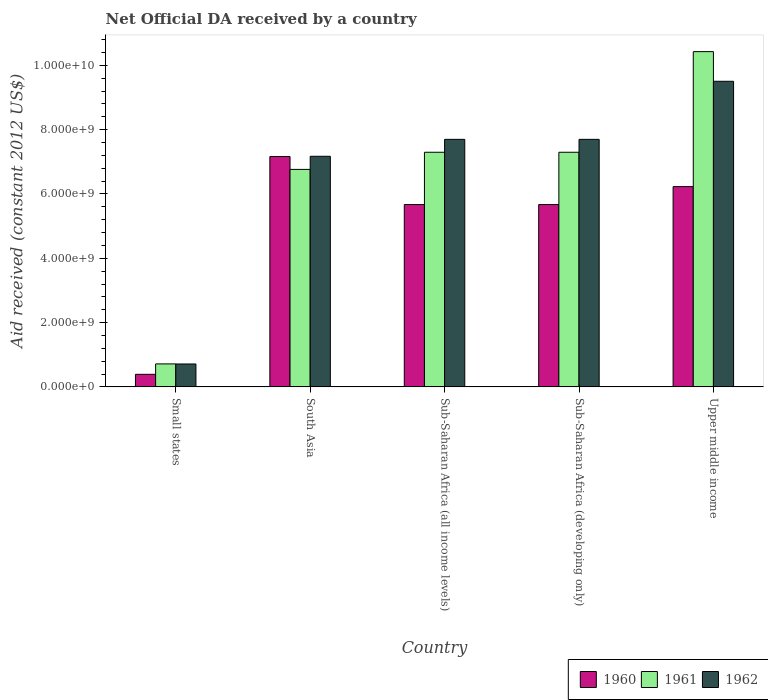How many different coloured bars are there?
Provide a short and direct response. 3. How many groups of bars are there?
Your answer should be compact. 5. How many bars are there on the 3rd tick from the left?
Make the answer very short. 3. What is the label of the 1st group of bars from the left?
Provide a succinct answer. Small states. In how many cases, is the number of bars for a given country not equal to the number of legend labels?
Your answer should be very brief. 0. What is the net official development assistance aid received in 1960 in Upper middle income?
Your answer should be very brief. 6.23e+09. Across all countries, what is the maximum net official development assistance aid received in 1960?
Provide a short and direct response. 7.17e+09. Across all countries, what is the minimum net official development assistance aid received in 1962?
Offer a very short reply. 7.12e+08. In which country was the net official development assistance aid received in 1962 maximum?
Provide a succinct answer. Upper middle income. In which country was the net official development assistance aid received in 1962 minimum?
Your answer should be very brief. Small states. What is the total net official development assistance aid received in 1962 in the graph?
Your response must be concise. 3.28e+1. What is the difference between the net official development assistance aid received in 1962 in South Asia and that in Sub-Saharan Africa (all income levels)?
Offer a very short reply. -5.27e+08. What is the difference between the net official development assistance aid received in 1961 in Small states and the net official development assistance aid received in 1962 in South Asia?
Provide a succinct answer. -6.46e+09. What is the average net official development assistance aid received in 1960 per country?
Offer a terse response. 5.03e+09. What is the difference between the net official development assistance aid received of/in 1960 and net official development assistance aid received of/in 1961 in Small states?
Provide a short and direct response. -3.24e+08. What is the ratio of the net official development assistance aid received in 1961 in Small states to that in Upper middle income?
Your answer should be very brief. 0.07. What is the difference between the highest and the second highest net official development assistance aid received in 1962?
Provide a short and direct response. 1.81e+09. What is the difference between the highest and the lowest net official development assistance aid received in 1961?
Give a very brief answer. 9.71e+09. In how many countries, is the net official development assistance aid received in 1962 greater than the average net official development assistance aid received in 1962 taken over all countries?
Offer a terse response. 4. Is it the case that in every country, the sum of the net official development assistance aid received in 1960 and net official development assistance aid received in 1961 is greater than the net official development assistance aid received in 1962?
Provide a short and direct response. Yes. How many bars are there?
Your answer should be compact. 15. How many countries are there in the graph?
Offer a terse response. 5. Does the graph contain any zero values?
Ensure brevity in your answer.  No. Where does the legend appear in the graph?
Your answer should be very brief. Bottom right. What is the title of the graph?
Give a very brief answer. Net Official DA received by a country. What is the label or title of the X-axis?
Keep it short and to the point. Country. What is the label or title of the Y-axis?
Your answer should be compact. Aid received (constant 2012 US$). What is the Aid received (constant 2012 US$) of 1960 in Small states?
Give a very brief answer. 3.90e+08. What is the Aid received (constant 2012 US$) in 1961 in Small states?
Provide a short and direct response. 7.15e+08. What is the Aid received (constant 2012 US$) in 1962 in Small states?
Your answer should be compact. 7.12e+08. What is the Aid received (constant 2012 US$) in 1960 in South Asia?
Your answer should be compact. 7.17e+09. What is the Aid received (constant 2012 US$) in 1961 in South Asia?
Keep it short and to the point. 6.76e+09. What is the Aid received (constant 2012 US$) in 1962 in South Asia?
Offer a very short reply. 7.17e+09. What is the Aid received (constant 2012 US$) in 1960 in Sub-Saharan Africa (all income levels)?
Provide a short and direct response. 5.67e+09. What is the Aid received (constant 2012 US$) of 1961 in Sub-Saharan Africa (all income levels)?
Provide a short and direct response. 7.30e+09. What is the Aid received (constant 2012 US$) of 1962 in Sub-Saharan Africa (all income levels)?
Offer a very short reply. 7.70e+09. What is the Aid received (constant 2012 US$) in 1960 in Sub-Saharan Africa (developing only)?
Give a very brief answer. 5.67e+09. What is the Aid received (constant 2012 US$) of 1961 in Sub-Saharan Africa (developing only)?
Offer a very short reply. 7.30e+09. What is the Aid received (constant 2012 US$) of 1962 in Sub-Saharan Africa (developing only)?
Your answer should be very brief. 7.70e+09. What is the Aid received (constant 2012 US$) in 1960 in Upper middle income?
Your answer should be very brief. 6.23e+09. What is the Aid received (constant 2012 US$) of 1961 in Upper middle income?
Offer a terse response. 1.04e+1. What is the Aid received (constant 2012 US$) in 1962 in Upper middle income?
Your answer should be compact. 9.51e+09. Across all countries, what is the maximum Aid received (constant 2012 US$) in 1960?
Ensure brevity in your answer.  7.17e+09. Across all countries, what is the maximum Aid received (constant 2012 US$) in 1961?
Your answer should be compact. 1.04e+1. Across all countries, what is the maximum Aid received (constant 2012 US$) in 1962?
Offer a very short reply. 9.51e+09. Across all countries, what is the minimum Aid received (constant 2012 US$) in 1960?
Offer a terse response. 3.90e+08. Across all countries, what is the minimum Aid received (constant 2012 US$) in 1961?
Keep it short and to the point. 7.15e+08. Across all countries, what is the minimum Aid received (constant 2012 US$) in 1962?
Provide a succinct answer. 7.12e+08. What is the total Aid received (constant 2012 US$) of 1960 in the graph?
Ensure brevity in your answer.  2.51e+1. What is the total Aid received (constant 2012 US$) of 1961 in the graph?
Offer a terse response. 3.25e+1. What is the total Aid received (constant 2012 US$) of 1962 in the graph?
Offer a terse response. 3.28e+1. What is the difference between the Aid received (constant 2012 US$) of 1960 in Small states and that in South Asia?
Give a very brief answer. -6.77e+09. What is the difference between the Aid received (constant 2012 US$) in 1961 in Small states and that in South Asia?
Make the answer very short. -6.05e+09. What is the difference between the Aid received (constant 2012 US$) of 1962 in Small states and that in South Asia?
Offer a very short reply. -6.46e+09. What is the difference between the Aid received (constant 2012 US$) of 1960 in Small states and that in Sub-Saharan Africa (all income levels)?
Your answer should be compact. -5.28e+09. What is the difference between the Aid received (constant 2012 US$) in 1961 in Small states and that in Sub-Saharan Africa (all income levels)?
Your response must be concise. -6.58e+09. What is the difference between the Aid received (constant 2012 US$) in 1962 in Small states and that in Sub-Saharan Africa (all income levels)?
Ensure brevity in your answer.  -6.99e+09. What is the difference between the Aid received (constant 2012 US$) of 1960 in Small states and that in Sub-Saharan Africa (developing only)?
Your answer should be compact. -5.28e+09. What is the difference between the Aid received (constant 2012 US$) of 1961 in Small states and that in Sub-Saharan Africa (developing only)?
Offer a very short reply. -6.58e+09. What is the difference between the Aid received (constant 2012 US$) in 1962 in Small states and that in Sub-Saharan Africa (developing only)?
Your answer should be very brief. -6.99e+09. What is the difference between the Aid received (constant 2012 US$) in 1960 in Small states and that in Upper middle income?
Provide a succinct answer. -5.84e+09. What is the difference between the Aid received (constant 2012 US$) in 1961 in Small states and that in Upper middle income?
Offer a very short reply. -9.71e+09. What is the difference between the Aid received (constant 2012 US$) of 1962 in Small states and that in Upper middle income?
Your answer should be very brief. -8.79e+09. What is the difference between the Aid received (constant 2012 US$) in 1960 in South Asia and that in Sub-Saharan Africa (all income levels)?
Offer a very short reply. 1.49e+09. What is the difference between the Aid received (constant 2012 US$) in 1961 in South Asia and that in Sub-Saharan Africa (all income levels)?
Offer a very short reply. -5.34e+08. What is the difference between the Aid received (constant 2012 US$) of 1962 in South Asia and that in Sub-Saharan Africa (all income levels)?
Provide a short and direct response. -5.27e+08. What is the difference between the Aid received (constant 2012 US$) of 1960 in South Asia and that in Sub-Saharan Africa (developing only)?
Your answer should be very brief. 1.49e+09. What is the difference between the Aid received (constant 2012 US$) in 1961 in South Asia and that in Sub-Saharan Africa (developing only)?
Make the answer very short. -5.34e+08. What is the difference between the Aid received (constant 2012 US$) in 1962 in South Asia and that in Sub-Saharan Africa (developing only)?
Keep it short and to the point. -5.27e+08. What is the difference between the Aid received (constant 2012 US$) of 1960 in South Asia and that in Upper middle income?
Offer a terse response. 9.35e+08. What is the difference between the Aid received (constant 2012 US$) of 1961 in South Asia and that in Upper middle income?
Ensure brevity in your answer.  -3.66e+09. What is the difference between the Aid received (constant 2012 US$) of 1962 in South Asia and that in Upper middle income?
Offer a very short reply. -2.33e+09. What is the difference between the Aid received (constant 2012 US$) of 1961 in Sub-Saharan Africa (all income levels) and that in Sub-Saharan Africa (developing only)?
Keep it short and to the point. 0. What is the difference between the Aid received (constant 2012 US$) in 1960 in Sub-Saharan Africa (all income levels) and that in Upper middle income?
Keep it short and to the point. -5.58e+08. What is the difference between the Aid received (constant 2012 US$) in 1961 in Sub-Saharan Africa (all income levels) and that in Upper middle income?
Ensure brevity in your answer.  -3.13e+09. What is the difference between the Aid received (constant 2012 US$) in 1962 in Sub-Saharan Africa (all income levels) and that in Upper middle income?
Ensure brevity in your answer.  -1.81e+09. What is the difference between the Aid received (constant 2012 US$) in 1960 in Sub-Saharan Africa (developing only) and that in Upper middle income?
Offer a very short reply. -5.58e+08. What is the difference between the Aid received (constant 2012 US$) in 1961 in Sub-Saharan Africa (developing only) and that in Upper middle income?
Your response must be concise. -3.13e+09. What is the difference between the Aid received (constant 2012 US$) of 1962 in Sub-Saharan Africa (developing only) and that in Upper middle income?
Your response must be concise. -1.81e+09. What is the difference between the Aid received (constant 2012 US$) of 1960 in Small states and the Aid received (constant 2012 US$) of 1961 in South Asia?
Your answer should be compact. -6.37e+09. What is the difference between the Aid received (constant 2012 US$) in 1960 in Small states and the Aid received (constant 2012 US$) in 1962 in South Asia?
Provide a short and direct response. -6.78e+09. What is the difference between the Aid received (constant 2012 US$) of 1961 in Small states and the Aid received (constant 2012 US$) of 1962 in South Asia?
Provide a short and direct response. -6.46e+09. What is the difference between the Aid received (constant 2012 US$) of 1960 in Small states and the Aid received (constant 2012 US$) of 1961 in Sub-Saharan Africa (all income levels)?
Provide a succinct answer. -6.91e+09. What is the difference between the Aid received (constant 2012 US$) in 1960 in Small states and the Aid received (constant 2012 US$) in 1962 in Sub-Saharan Africa (all income levels)?
Provide a short and direct response. -7.31e+09. What is the difference between the Aid received (constant 2012 US$) in 1961 in Small states and the Aid received (constant 2012 US$) in 1962 in Sub-Saharan Africa (all income levels)?
Offer a very short reply. -6.99e+09. What is the difference between the Aid received (constant 2012 US$) in 1960 in Small states and the Aid received (constant 2012 US$) in 1961 in Sub-Saharan Africa (developing only)?
Your answer should be compact. -6.91e+09. What is the difference between the Aid received (constant 2012 US$) in 1960 in Small states and the Aid received (constant 2012 US$) in 1962 in Sub-Saharan Africa (developing only)?
Ensure brevity in your answer.  -7.31e+09. What is the difference between the Aid received (constant 2012 US$) of 1961 in Small states and the Aid received (constant 2012 US$) of 1962 in Sub-Saharan Africa (developing only)?
Provide a succinct answer. -6.99e+09. What is the difference between the Aid received (constant 2012 US$) of 1960 in Small states and the Aid received (constant 2012 US$) of 1961 in Upper middle income?
Ensure brevity in your answer.  -1.00e+1. What is the difference between the Aid received (constant 2012 US$) of 1960 in Small states and the Aid received (constant 2012 US$) of 1962 in Upper middle income?
Provide a succinct answer. -9.12e+09. What is the difference between the Aid received (constant 2012 US$) of 1961 in Small states and the Aid received (constant 2012 US$) of 1962 in Upper middle income?
Your answer should be very brief. -8.79e+09. What is the difference between the Aid received (constant 2012 US$) of 1960 in South Asia and the Aid received (constant 2012 US$) of 1961 in Sub-Saharan Africa (all income levels)?
Ensure brevity in your answer.  -1.33e+08. What is the difference between the Aid received (constant 2012 US$) of 1960 in South Asia and the Aid received (constant 2012 US$) of 1962 in Sub-Saharan Africa (all income levels)?
Your answer should be very brief. -5.35e+08. What is the difference between the Aid received (constant 2012 US$) in 1961 in South Asia and the Aid received (constant 2012 US$) in 1962 in Sub-Saharan Africa (all income levels)?
Provide a short and direct response. -9.35e+08. What is the difference between the Aid received (constant 2012 US$) in 1960 in South Asia and the Aid received (constant 2012 US$) in 1961 in Sub-Saharan Africa (developing only)?
Your response must be concise. -1.33e+08. What is the difference between the Aid received (constant 2012 US$) of 1960 in South Asia and the Aid received (constant 2012 US$) of 1962 in Sub-Saharan Africa (developing only)?
Ensure brevity in your answer.  -5.35e+08. What is the difference between the Aid received (constant 2012 US$) in 1961 in South Asia and the Aid received (constant 2012 US$) in 1962 in Sub-Saharan Africa (developing only)?
Make the answer very short. -9.35e+08. What is the difference between the Aid received (constant 2012 US$) in 1960 in South Asia and the Aid received (constant 2012 US$) in 1961 in Upper middle income?
Your answer should be compact. -3.26e+09. What is the difference between the Aid received (constant 2012 US$) of 1960 in South Asia and the Aid received (constant 2012 US$) of 1962 in Upper middle income?
Your answer should be compact. -2.34e+09. What is the difference between the Aid received (constant 2012 US$) in 1961 in South Asia and the Aid received (constant 2012 US$) in 1962 in Upper middle income?
Offer a very short reply. -2.74e+09. What is the difference between the Aid received (constant 2012 US$) in 1960 in Sub-Saharan Africa (all income levels) and the Aid received (constant 2012 US$) in 1961 in Sub-Saharan Africa (developing only)?
Your response must be concise. -1.63e+09. What is the difference between the Aid received (constant 2012 US$) in 1960 in Sub-Saharan Africa (all income levels) and the Aid received (constant 2012 US$) in 1962 in Sub-Saharan Africa (developing only)?
Give a very brief answer. -2.03e+09. What is the difference between the Aid received (constant 2012 US$) in 1961 in Sub-Saharan Africa (all income levels) and the Aid received (constant 2012 US$) in 1962 in Sub-Saharan Africa (developing only)?
Ensure brevity in your answer.  -4.02e+08. What is the difference between the Aid received (constant 2012 US$) in 1960 in Sub-Saharan Africa (all income levels) and the Aid received (constant 2012 US$) in 1961 in Upper middle income?
Make the answer very short. -4.76e+09. What is the difference between the Aid received (constant 2012 US$) of 1960 in Sub-Saharan Africa (all income levels) and the Aid received (constant 2012 US$) of 1962 in Upper middle income?
Provide a succinct answer. -3.83e+09. What is the difference between the Aid received (constant 2012 US$) of 1961 in Sub-Saharan Africa (all income levels) and the Aid received (constant 2012 US$) of 1962 in Upper middle income?
Keep it short and to the point. -2.21e+09. What is the difference between the Aid received (constant 2012 US$) in 1960 in Sub-Saharan Africa (developing only) and the Aid received (constant 2012 US$) in 1961 in Upper middle income?
Provide a short and direct response. -4.76e+09. What is the difference between the Aid received (constant 2012 US$) in 1960 in Sub-Saharan Africa (developing only) and the Aid received (constant 2012 US$) in 1962 in Upper middle income?
Provide a succinct answer. -3.83e+09. What is the difference between the Aid received (constant 2012 US$) in 1961 in Sub-Saharan Africa (developing only) and the Aid received (constant 2012 US$) in 1962 in Upper middle income?
Ensure brevity in your answer.  -2.21e+09. What is the average Aid received (constant 2012 US$) of 1960 per country?
Provide a succinct answer. 5.03e+09. What is the average Aid received (constant 2012 US$) of 1961 per country?
Make the answer very short. 6.50e+09. What is the average Aid received (constant 2012 US$) in 1962 per country?
Your answer should be very brief. 6.56e+09. What is the difference between the Aid received (constant 2012 US$) of 1960 and Aid received (constant 2012 US$) of 1961 in Small states?
Provide a succinct answer. -3.24e+08. What is the difference between the Aid received (constant 2012 US$) in 1960 and Aid received (constant 2012 US$) in 1962 in Small states?
Provide a short and direct response. -3.22e+08. What is the difference between the Aid received (constant 2012 US$) in 1961 and Aid received (constant 2012 US$) in 1962 in Small states?
Keep it short and to the point. 2.71e+06. What is the difference between the Aid received (constant 2012 US$) in 1960 and Aid received (constant 2012 US$) in 1961 in South Asia?
Your response must be concise. 4.00e+08. What is the difference between the Aid received (constant 2012 US$) in 1960 and Aid received (constant 2012 US$) in 1962 in South Asia?
Your answer should be very brief. -8.03e+06. What is the difference between the Aid received (constant 2012 US$) in 1961 and Aid received (constant 2012 US$) in 1962 in South Asia?
Ensure brevity in your answer.  -4.08e+08. What is the difference between the Aid received (constant 2012 US$) in 1960 and Aid received (constant 2012 US$) in 1961 in Sub-Saharan Africa (all income levels)?
Give a very brief answer. -1.63e+09. What is the difference between the Aid received (constant 2012 US$) in 1960 and Aid received (constant 2012 US$) in 1962 in Sub-Saharan Africa (all income levels)?
Give a very brief answer. -2.03e+09. What is the difference between the Aid received (constant 2012 US$) in 1961 and Aid received (constant 2012 US$) in 1962 in Sub-Saharan Africa (all income levels)?
Your response must be concise. -4.02e+08. What is the difference between the Aid received (constant 2012 US$) of 1960 and Aid received (constant 2012 US$) of 1961 in Sub-Saharan Africa (developing only)?
Provide a succinct answer. -1.63e+09. What is the difference between the Aid received (constant 2012 US$) in 1960 and Aid received (constant 2012 US$) in 1962 in Sub-Saharan Africa (developing only)?
Your answer should be very brief. -2.03e+09. What is the difference between the Aid received (constant 2012 US$) of 1961 and Aid received (constant 2012 US$) of 1962 in Sub-Saharan Africa (developing only)?
Give a very brief answer. -4.02e+08. What is the difference between the Aid received (constant 2012 US$) in 1960 and Aid received (constant 2012 US$) in 1961 in Upper middle income?
Ensure brevity in your answer.  -4.20e+09. What is the difference between the Aid received (constant 2012 US$) in 1960 and Aid received (constant 2012 US$) in 1962 in Upper middle income?
Make the answer very short. -3.28e+09. What is the difference between the Aid received (constant 2012 US$) in 1961 and Aid received (constant 2012 US$) in 1962 in Upper middle income?
Give a very brief answer. 9.22e+08. What is the ratio of the Aid received (constant 2012 US$) of 1960 in Small states to that in South Asia?
Provide a succinct answer. 0.05. What is the ratio of the Aid received (constant 2012 US$) in 1961 in Small states to that in South Asia?
Your answer should be compact. 0.11. What is the ratio of the Aid received (constant 2012 US$) of 1962 in Small states to that in South Asia?
Your answer should be compact. 0.1. What is the ratio of the Aid received (constant 2012 US$) in 1960 in Small states to that in Sub-Saharan Africa (all income levels)?
Offer a terse response. 0.07. What is the ratio of the Aid received (constant 2012 US$) in 1961 in Small states to that in Sub-Saharan Africa (all income levels)?
Your response must be concise. 0.1. What is the ratio of the Aid received (constant 2012 US$) of 1962 in Small states to that in Sub-Saharan Africa (all income levels)?
Provide a short and direct response. 0.09. What is the ratio of the Aid received (constant 2012 US$) of 1960 in Small states to that in Sub-Saharan Africa (developing only)?
Provide a short and direct response. 0.07. What is the ratio of the Aid received (constant 2012 US$) in 1961 in Small states to that in Sub-Saharan Africa (developing only)?
Offer a terse response. 0.1. What is the ratio of the Aid received (constant 2012 US$) of 1962 in Small states to that in Sub-Saharan Africa (developing only)?
Your answer should be compact. 0.09. What is the ratio of the Aid received (constant 2012 US$) of 1960 in Small states to that in Upper middle income?
Ensure brevity in your answer.  0.06. What is the ratio of the Aid received (constant 2012 US$) of 1961 in Small states to that in Upper middle income?
Your answer should be very brief. 0.07. What is the ratio of the Aid received (constant 2012 US$) in 1962 in Small states to that in Upper middle income?
Your answer should be compact. 0.07. What is the ratio of the Aid received (constant 2012 US$) of 1960 in South Asia to that in Sub-Saharan Africa (all income levels)?
Offer a terse response. 1.26. What is the ratio of the Aid received (constant 2012 US$) of 1961 in South Asia to that in Sub-Saharan Africa (all income levels)?
Offer a very short reply. 0.93. What is the ratio of the Aid received (constant 2012 US$) in 1962 in South Asia to that in Sub-Saharan Africa (all income levels)?
Your response must be concise. 0.93. What is the ratio of the Aid received (constant 2012 US$) in 1960 in South Asia to that in Sub-Saharan Africa (developing only)?
Ensure brevity in your answer.  1.26. What is the ratio of the Aid received (constant 2012 US$) in 1961 in South Asia to that in Sub-Saharan Africa (developing only)?
Give a very brief answer. 0.93. What is the ratio of the Aid received (constant 2012 US$) of 1962 in South Asia to that in Sub-Saharan Africa (developing only)?
Your answer should be compact. 0.93. What is the ratio of the Aid received (constant 2012 US$) in 1960 in South Asia to that in Upper middle income?
Make the answer very short. 1.15. What is the ratio of the Aid received (constant 2012 US$) in 1961 in South Asia to that in Upper middle income?
Provide a succinct answer. 0.65. What is the ratio of the Aid received (constant 2012 US$) in 1962 in South Asia to that in Upper middle income?
Offer a very short reply. 0.75. What is the ratio of the Aid received (constant 2012 US$) of 1962 in Sub-Saharan Africa (all income levels) to that in Sub-Saharan Africa (developing only)?
Your response must be concise. 1. What is the ratio of the Aid received (constant 2012 US$) in 1960 in Sub-Saharan Africa (all income levels) to that in Upper middle income?
Make the answer very short. 0.91. What is the ratio of the Aid received (constant 2012 US$) of 1961 in Sub-Saharan Africa (all income levels) to that in Upper middle income?
Your answer should be compact. 0.7. What is the ratio of the Aid received (constant 2012 US$) of 1962 in Sub-Saharan Africa (all income levels) to that in Upper middle income?
Provide a succinct answer. 0.81. What is the ratio of the Aid received (constant 2012 US$) in 1960 in Sub-Saharan Africa (developing only) to that in Upper middle income?
Give a very brief answer. 0.91. What is the ratio of the Aid received (constant 2012 US$) of 1961 in Sub-Saharan Africa (developing only) to that in Upper middle income?
Your response must be concise. 0.7. What is the ratio of the Aid received (constant 2012 US$) in 1962 in Sub-Saharan Africa (developing only) to that in Upper middle income?
Offer a very short reply. 0.81. What is the difference between the highest and the second highest Aid received (constant 2012 US$) in 1960?
Keep it short and to the point. 9.35e+08. What is the difference between the highest and the second highest Aid received (constant 2012 US$) in 1961?
Offer a very short reply. 3.13e+09. What is the difference between the highest and the second highest Aid received (constant 2012 US$) in 1962?
Offer a very short reply. 1.81e+09. What is the difference between the highest and the lowest Aid received (constant 2012 US$) of 1960?
Offer a terse response. 6.77e+09. What is the difference between the highest and the lowest Aid received (constant 2012 US$) of 1961?
Give a very brief answer. 9.71e+09. What is the difference between the highest and the lowest Aid received (constant 2012 US$) in 1962?
Your response must be concise. 8.79e+09. 